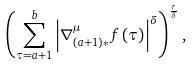Convert formula to latex. <formula><loc_0><loc_0><loc_500><loc_500>\left ( \sum _ { \tau = a + 1 } ^ { b } \left | \nabla _ { \left ( a + 1 \right ) \ast } ^ { \mu } f \left ( \tau \right ) \right | ^ { \delta } \right ) ^ { \frac { r } { \delta } } ,</formula> 